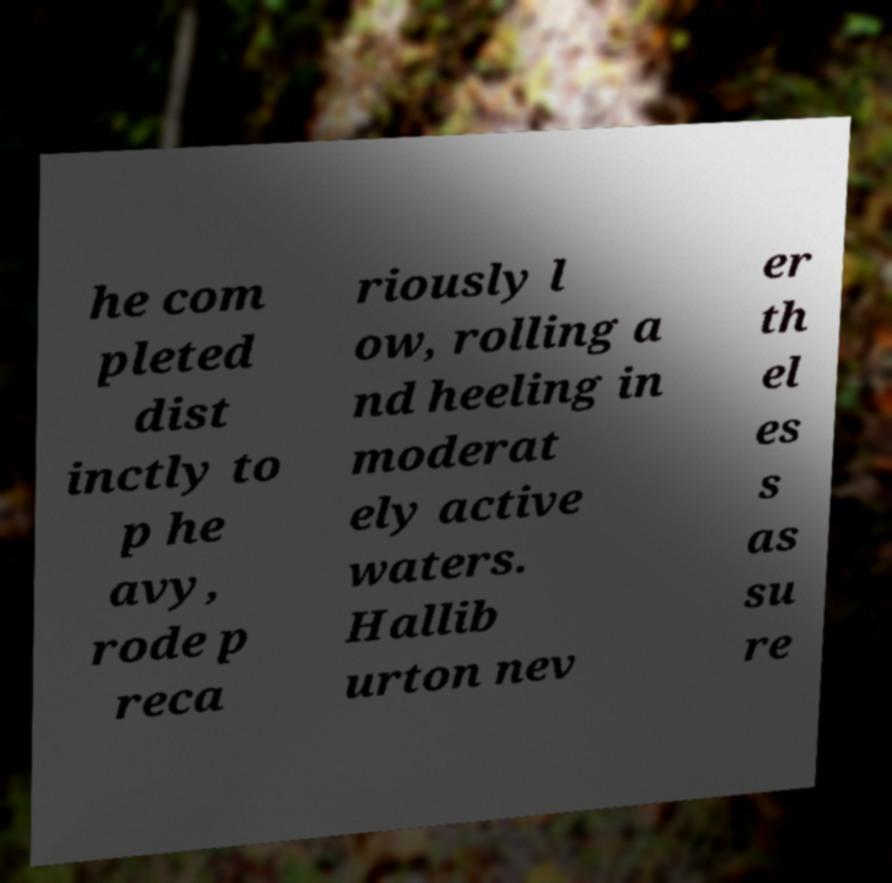What messages or text are displayed in this image? I need them in a readable, typed format. he com pleted dist inctly to p he avy, rode p reca riously l ow, rolling a nd heeling in moderat ely active waters. Hallib urton nev er th el es s as su re 